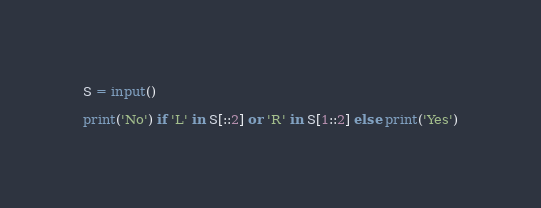<code> <loc_0><loc_0><loc_500><loc_500><_Python_>S = input()

print('No') if 'L' in S[::2] or 'R' in S[1::2] else print('Yes')
</code> 